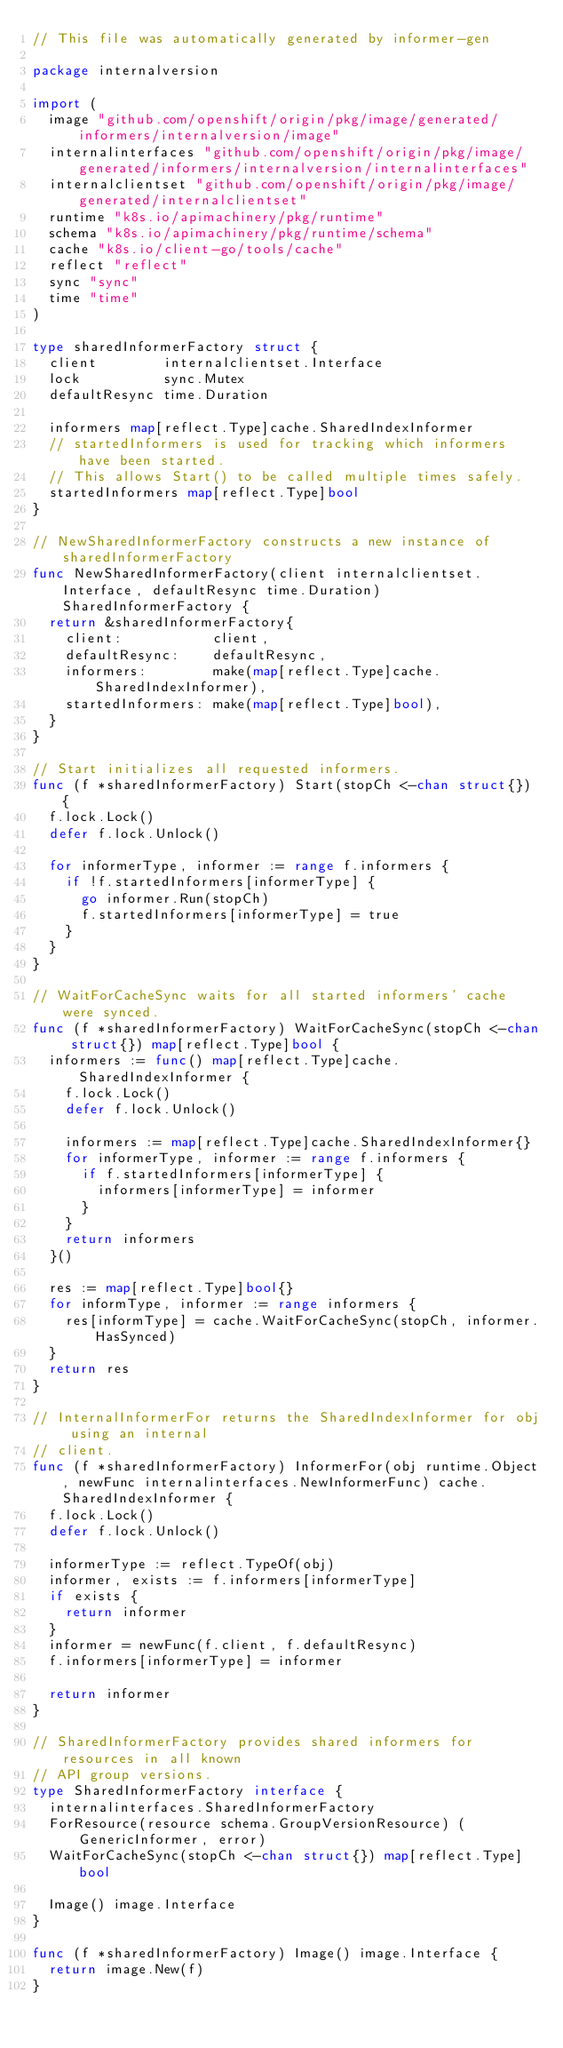Convert code to text. <code><loc_0><loc_0><loc_500><loc_500><_Go_>// This file was automatically generated by informer-gen

package internalversion

import (
	image "github.com/openshift/origin/pkg/image/generated/informers/internalversion/image"
	internalinterfaces "github.com/openshift/origin/pkg/image/generated/informers/internalversion/internalinterfaces"
	internalclientset "github.com/openshift/origin/pkg/image/generated/internalclientset"
	runtime "k8s.io/apimachinery/pkg/runtime"
	schema "k8s.io/apimachinery/pkg/runtime/schema"
	cache "k8s.io/client-go/tools/cache"
	reflect "reflect"
	sync "sync"
	time "time"
)

type sharedInformerFactory struct {
	client        internalclientset.Interface
	lock          sync.Mutex
	defaultResync time.Duration

	informers map[reflect.Type]cache.SharedIndexInformer
	// startedInformers is used for tracking which informers have been started.
	// This allows Start() to be called multiple times safely.
	startedInformers map[reflect.Type]bool
}

// NewSharedInformerFactory constructs a new instance of sharedInformerFactory
func NewSharedInformerFactory(client internalclientset.Interface, defaultResync time.Duration) SharedInformerFactory {
	return &sharedInformerFactory{
		client:           client,
		defaultResync:    defaultResync,
		informers:        make(map[reflect.Type]cache.SharedIndexInformer),
		startedInformers: make(map[reflect.Type]bool),
	}
}

// Start initializes all requested informers.
func (f *sharedInformerFactory) Start(stopCh <-chan struct{}) {
	f.lock.Lock()
	defer f.lock.Unlock()

	for informerType, informer := range f.informers {
		if !f.startedInformers[informerType] {
			go informer.Run(stopCh)
			f.startedInformers[informerType] = true
		}
	}
}

// WaitForCacheSync waits for all started informers' cache were synced.
func (f *sharedInformerFactory) WaitForCacheSync(stopCh <-chan struct{}) map[reflect.Type]bool {
	informers := func() map[reflect.Type]cache.SharedIndexInformer {
		f.lock.Lock()
		defer f.lock.Unlock()

		informers := map[reflect.Type]cache.SharedIndexInformer{}
		for informerType, informer := range f.informers {
			if f.startedInformers[informerType] {
				informers[informerType] = informer
			}
		}
		return informers
	}()

	res := map[reflect.Type]bool{}
	for informType, informer := range informers {
		res[informType] = cache.WaitForCacheSync(stopCh, informer.HasSynced)
	}
	return res
}

// InternalInformerFor returns the SharedIndexInformer for obj using an internal
// client.
func (f *sharedInformerFactory) InformerFor(obj runtime.Object, newFunc internalinterfaces.NewInformerFunc) cache.SharedIndexInformer {
	f.lock.Lock()
	defer f.lock.Unlock()

	informerType := reflect.TypeOf(obj)
	informer, exists := f.informers[informerType]
	if exists {
		return informer
	}
	informer = newFunc(f.client, f.defaultResync)
	f.informers[informerType] = informer

	return informer
}

// SharedInformerFactory provides shared informers for resources in all known
// API group versions.
type SharedInformerFactory interface {
	internalinterfaces.SharedInformerFactory
	ForResource(resource schema.GroupVersionResource) (GenericInformer, error)
	WaitForCacheSync(stopCh <-chan struct{}) map[reflect.Type]bool

	Image() image.Interface
}

func (f *sharedInformerFactory) Image() image.Interface {
	return image.New(f)
}
</code> 